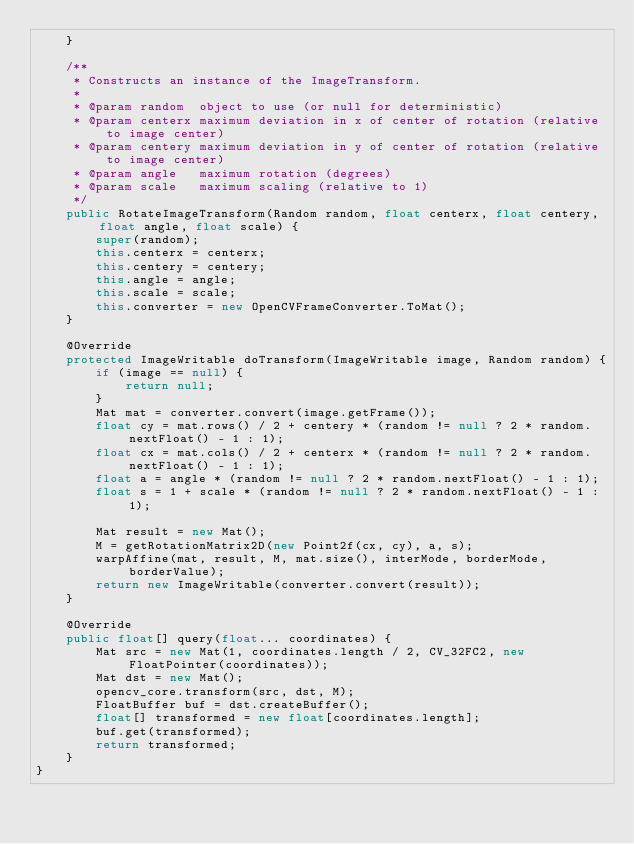Convert code to text. <code><loc_0><loc_0><loc_500><loc_500><_Java_>    }

    /**
     * Constructs an instance of the ImageTransform.
     *
     * @param random  object to use (or null for deterministic)
     * @param centerx maximum deviation in x of center of rotation (relative to image center)
     * @param centery maximum deviation in y of center of rotation (relative to image center)
     * @param angle   maximum rotation (degrees)
     * @param scale   maximum scaling (relative to 1)
     */
    public RotateImageTransform(Random random, float centerx, float centery, float angle, float scale) {
        super(random);
        this.centerx = centerx;
        this.centery = centery;
        this.angle = angle;
        this.scale = scale;
        this.converter = new OpenCVFrameConverter.ToMat();
    }

    @Override
    protected ImageWritable doTransform(ImageWritable image, Random random) {
        if (image == null) {
            return null;
        }
        Mat mat = converter.convert(image.getFrame());
        float cy = mat.rows() / 2 + centery * (random != null ? 2 * random.nextFloat() - 1 : 1);
        float cx = mat.cols() / 2 + centerx * (random != null ? 2 * random.nextFloat() - 1 : 1);
        float a = angle * (random != null ? 2 * random.nextFloat() - 1 : 1);
        float s = 1 + scale * (random != null ? 2 * random.nextFloat() - 1 : 1);

        Mat result = new Mat();
        M = getRotationMatrix2D(new Point2f(cx, cy), a, s);
        warpAffine(mat, result, M, mat.size(), interMode, borderMode, borderValue);
        return new ImageWritable(converter.convert(result));
    }

    @Override
    public float[] query(float... coordinates) {
        Mat src = new Mat(1, coordinates.length / 2, CV_32FC2, new FloatPointer(coordinates));
        Mat dst = new Mat();
        opencv_core.transform(src, dst, M);
        FloatBuffer buf = dst.createBuffer();
        float[] transformed = new float[coordinates.length];
        buf.get(transformed);
        return transformed;
    }
}
</code> 